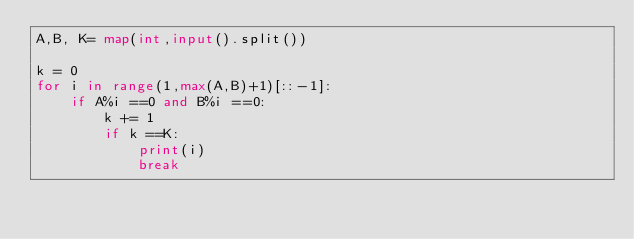<code> <loc_0><loc_0><loc_500><loc_500><_Python_>A,B, K= map(int,input().split())

k = 0
for i in range(1,max(A,B)+1)[::-1]:
    if A%i ==0 and B%i ==0:
        k += 1
        if k ==K:
            print(i)
            break</code> 